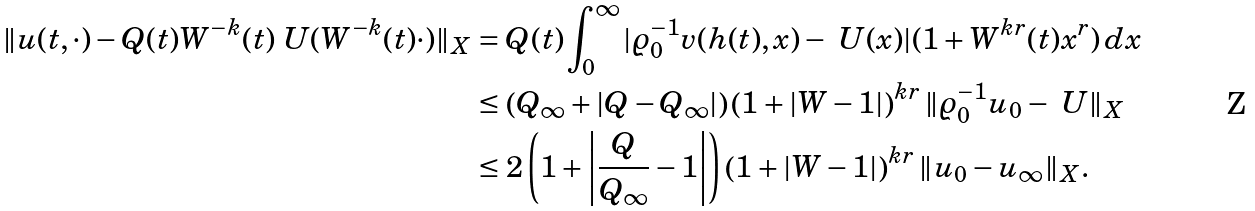Convert formula to latex. <formula><loc_0><loc_0><loc_500><loc_500>\| u ( t , \cdot ) - Q ( t ) W ^ { - k } ( t ) \ U ( W ^ { - k } ( t ) \cdot ) \| _ { X } & = Q ( t ) \int _ { 0 } ^ { \infty } | \varrho _ { 0 } ^ { - 1 } v ( h ( t ) , x ) - \ U ( x ) | ( 1 + W ^ { k r } ( t ) x ^ { r } ) \, d x \\ & \leq \left ( Q _ { \infty } + | Q - Q _ { \infty } | \right ) \left ( 1 + | W - 1 | \right ) ^ { k r } \| \varrho _ { 0 } ^ { - 1 } u _ { 0 } - \ U \| _ { X } \\ & \leq 2 \left ( 1 + \left | \frac { Q } { Q _ { \infty } } - 1 \right | \right ) \left ( 1 + | W - 1 | \right ) ^ { k r } \| u _ { 0 } - u _ { \infty } \| _ { X } .</formula> 